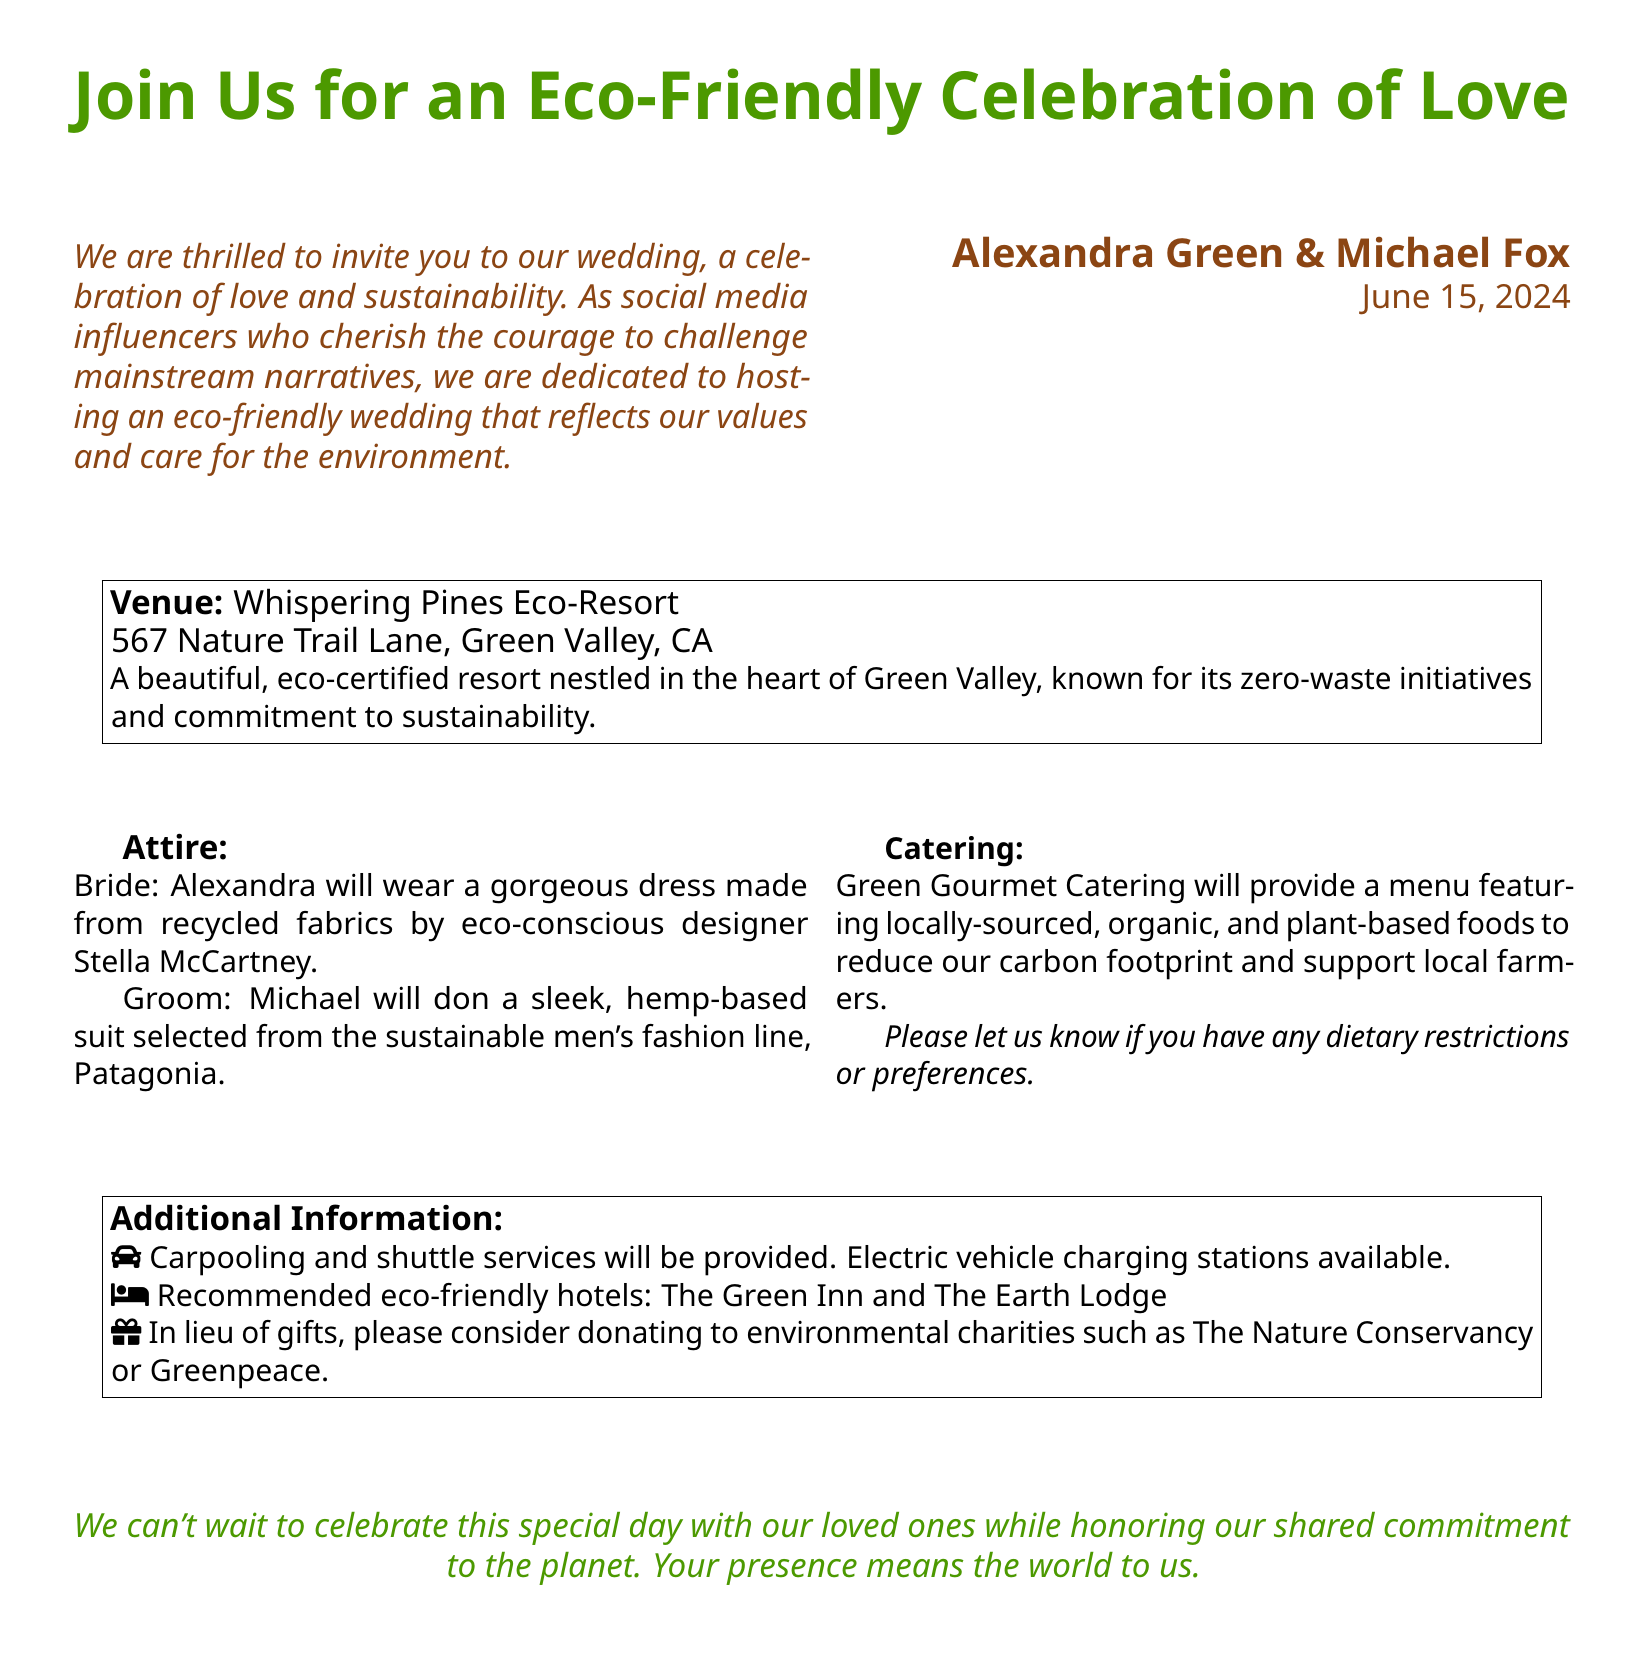what is the date of the wedding? The date of the wedding is explicitly stated in the document.
Answer: June 15, 2024 who are the couple getting married? The document provides the names of the couple specifically at the center.
Answer: Alexandra Green & Michael Fox what is the name of the venue? The venue name is mentioned in a specific section of the document.
Answer: Whispering Pines Eco-Resort what type of attire will the bride wear? The document specifies the type of attire for the bride in detail.
Answer: Recycled fabrics dress what kind of catering will be provided? The catering is discussed and defined in a dedicated section of the document.
Answer: Locally-sourced, organic, and plant-based foods how is the couple addressing transportation for guests? The document mentions transportation solutions for the guests.
Answer: Carpooling and shuttle services what is requested instead of gifts? The document explicitly states a request regarding gifts in a specific section.
Answer: Donations to environmental charities who designed the bride's dress? The designer of the bride's dress is mentioned in the document.
Answer: Stella McCartney what is the purpose of the celebration according to the couple? The purpose of the celebration is summarized in a statement within the document.
Answer: Eco-friendly celebration of love 